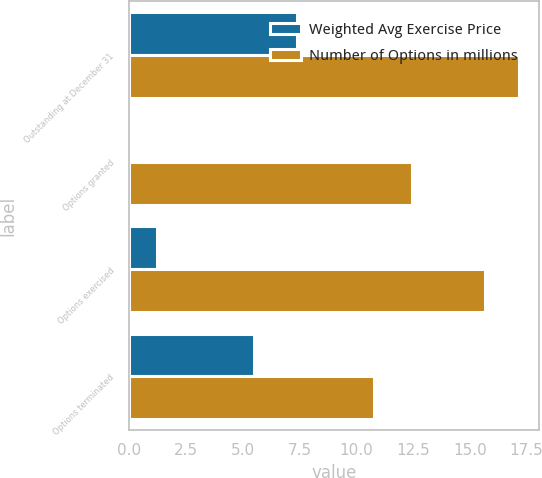Convert chart to OTSL. <chart><loc_0><loc_0><loc_500><loc_500><stacked_bar_chart><ecel><fcel>Outstanding at December 31<fcel>Options granted<fcel>Options exercised<fcel>Options terminated<nl><fcel>Weighted Avg Exercise Price<fcel>7.4<fcel>0.1<fcel>1.2<fcel>5.5<nl><fcel>Number of Options in millions<fcel>17.18<fcel>12.46<fcel>15.66<fcel>10.78<nl></chart> 